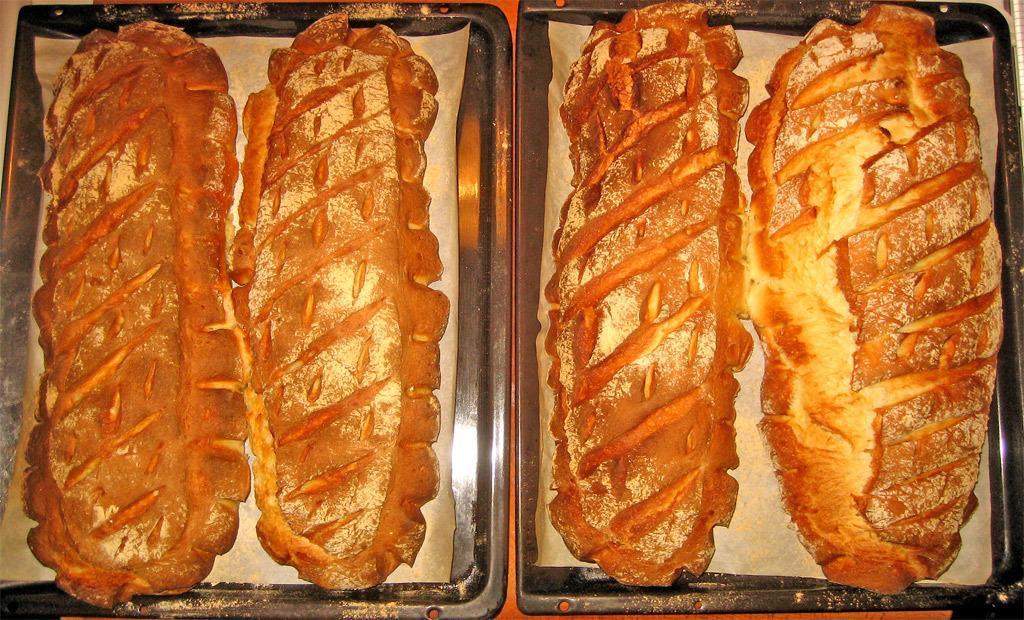In one or two sentences, can you explain what this image depicts? In this image we can see two trays with food items. 